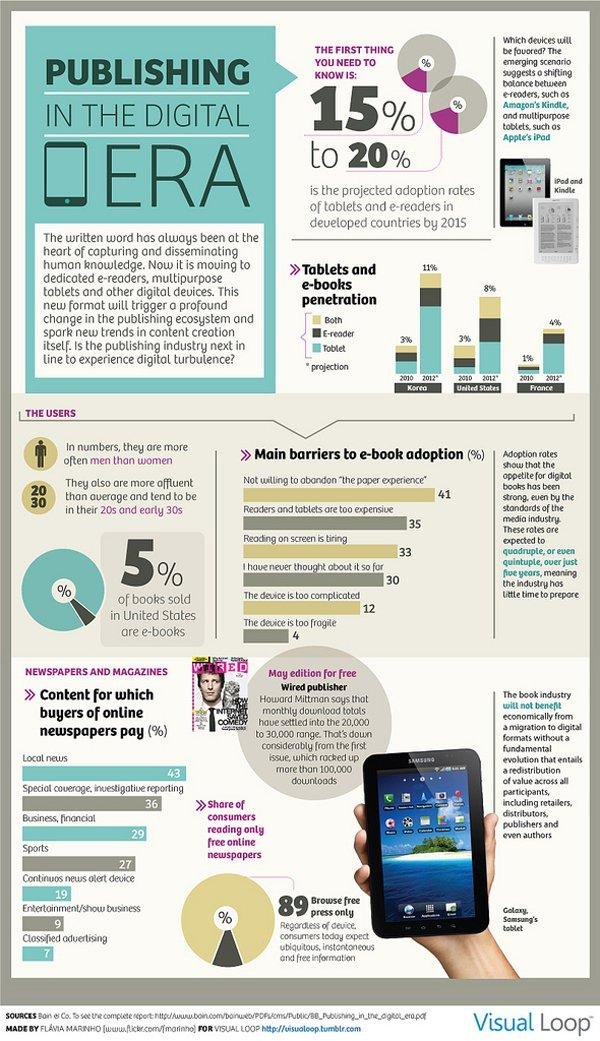List a handful of essential elements in this visual. According to projections, it is expected that Korea will have the highest penetration of tablets and e-books in 2012. It is commonly believed that men use ebooks more than women. A recent survey found that 28% of buyers of online newspapers pay for continuous news alert devices and entertainment/show business. In 2012, it is projected that tablets will be the most widely used device in France. Of those surveyed, 16% believe that the device is too complicated and fragile. 